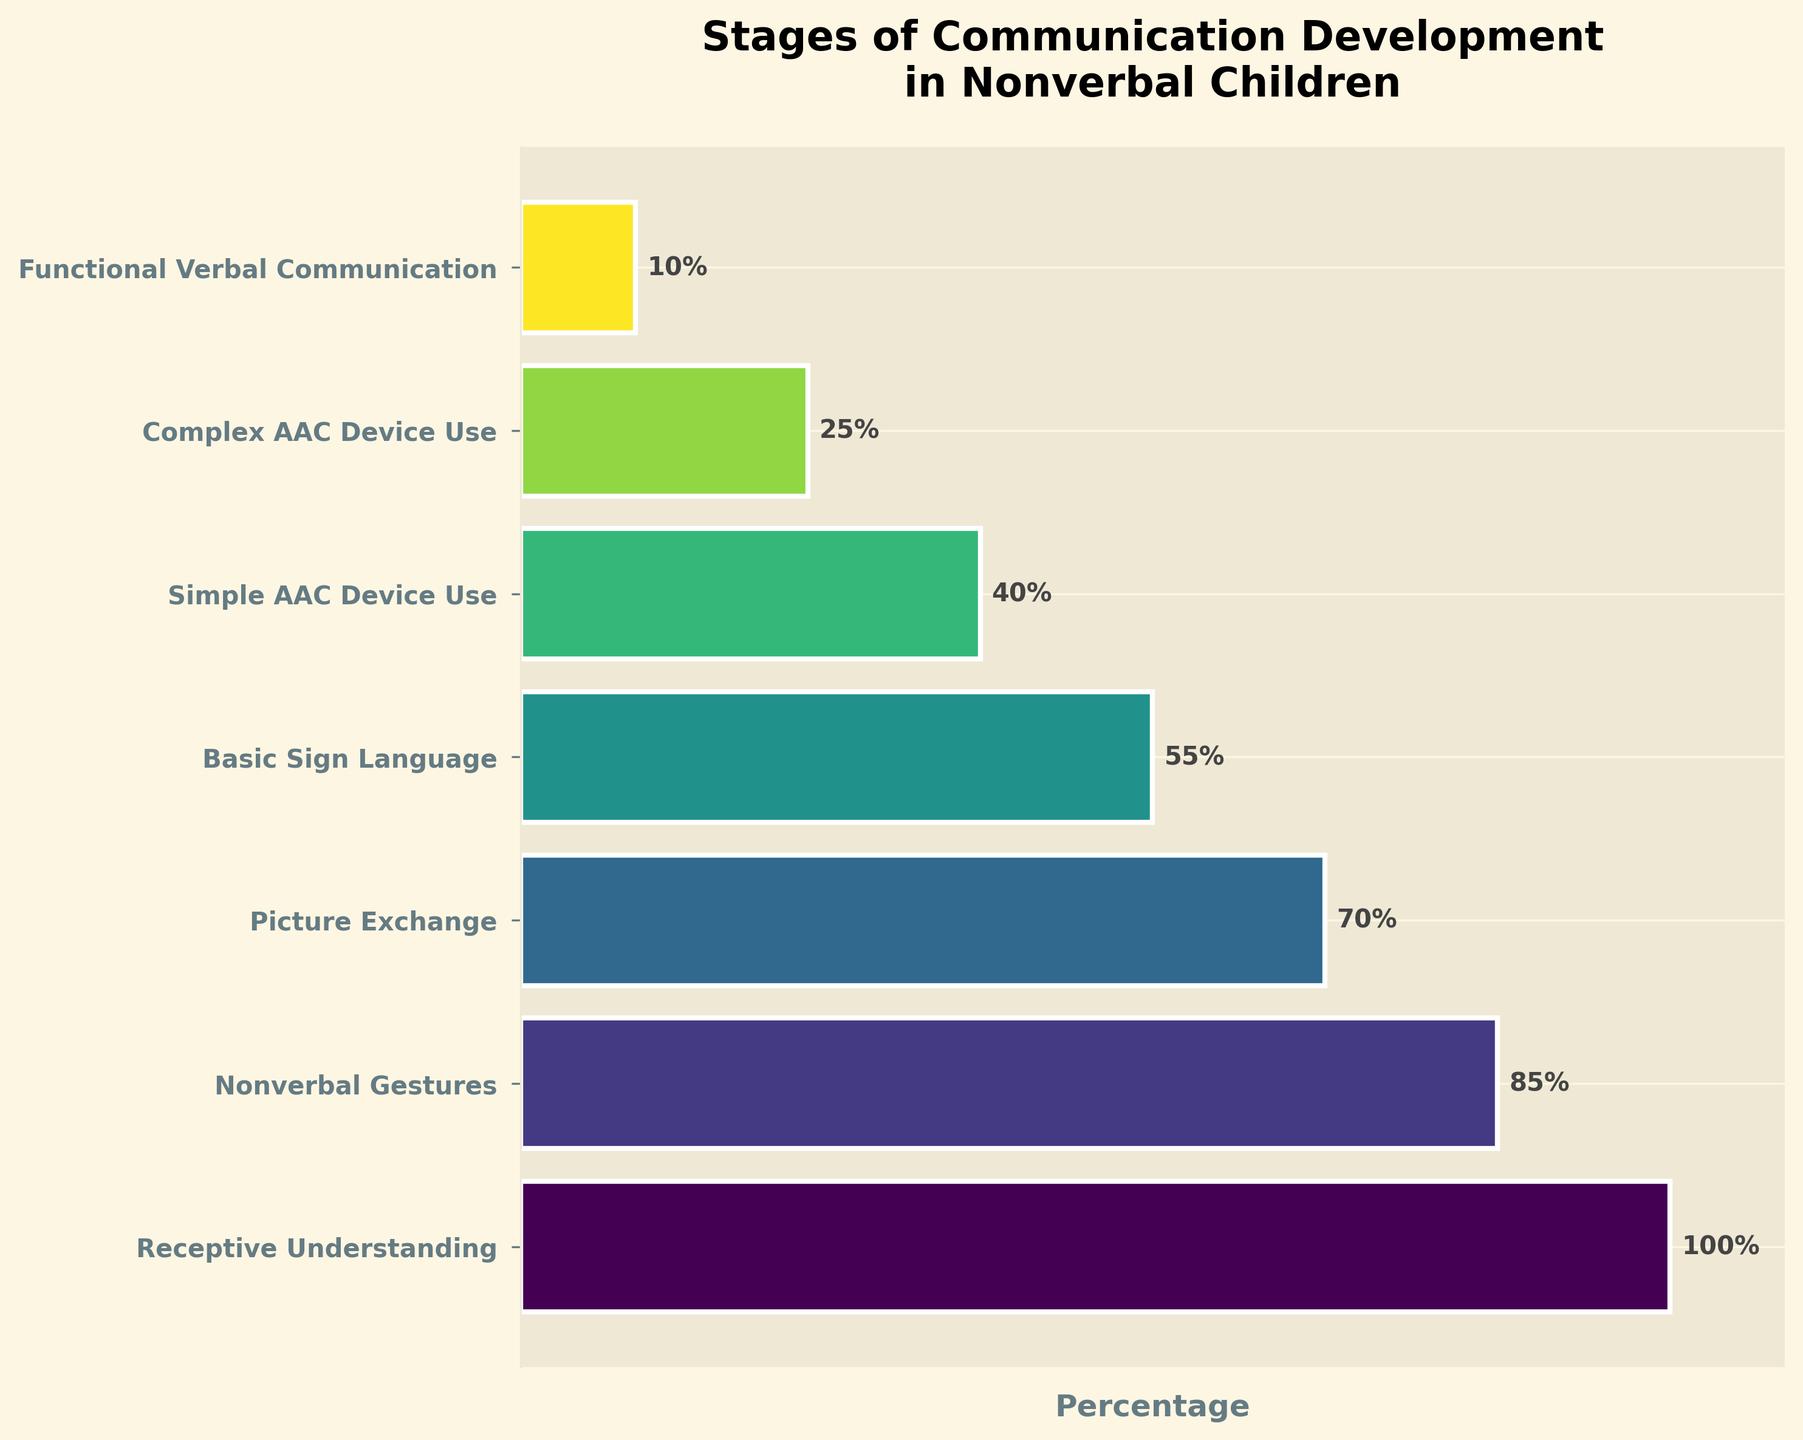What is the title of the funnel chart? The title is usually displayed at the top of the chart. In this case, the chart title is "Stages of Communication Development in Nonverbal Children".
Answer: Stages of Communication Development in Nonverbal Children What is the percentage for the "Basic Sign Language" stage? The percentage values are shown next to the bars. The "Basic Sign Language" stage has a percentage of 55%.
Answer: 55% How many stages are shown in the chart? Each bar represents a stage, and there are 7 bars shown in the chart.
Answer: 7 What is the difference in percentage between "Receptive Understanding" and "Functional Verbal Communication"? Subtract the percentage of "Functional Verbal Communication" (10%) from "Receptive Understanding" (100%). The difference is 100% - 10% = 90%.
Answer: 90% Which stage has a percentage of 70%? The percentage values are labeled next to each bar. The "Picture Exchange" stage is labeled with 70%.
Answer: Picture Exchange What is the average percentage of the first three stages? The first three stages are "Receptive Understanding" (100%), "Nonverbal Gestures" (85%), and "Picture Exchange" (70%). The average is calculated as (100 + 85 + 70) / 3 = 85%.
Answer: 85% Which stage comes after "Nonverbal Gestures"? The stages are listed in order from top to bottom. After "Nonverbal Gestures" (85%) comes "Picture Exchange" (70%).
Answer: Picture Exchange Is "Functional Verbal Communication" the stage with the lowest percentage? Yes, by looking at the percentages, "Functional Verbal Communication" at 10% is the lowest.
Answer: Yes What stage falls directly in the middle in terms of percentage? Arrange the stages by percentage and find the middle stage. The middle stage by percentage is the "Basic Sign Language" at 55%.
Answer: Basic Sign Language 